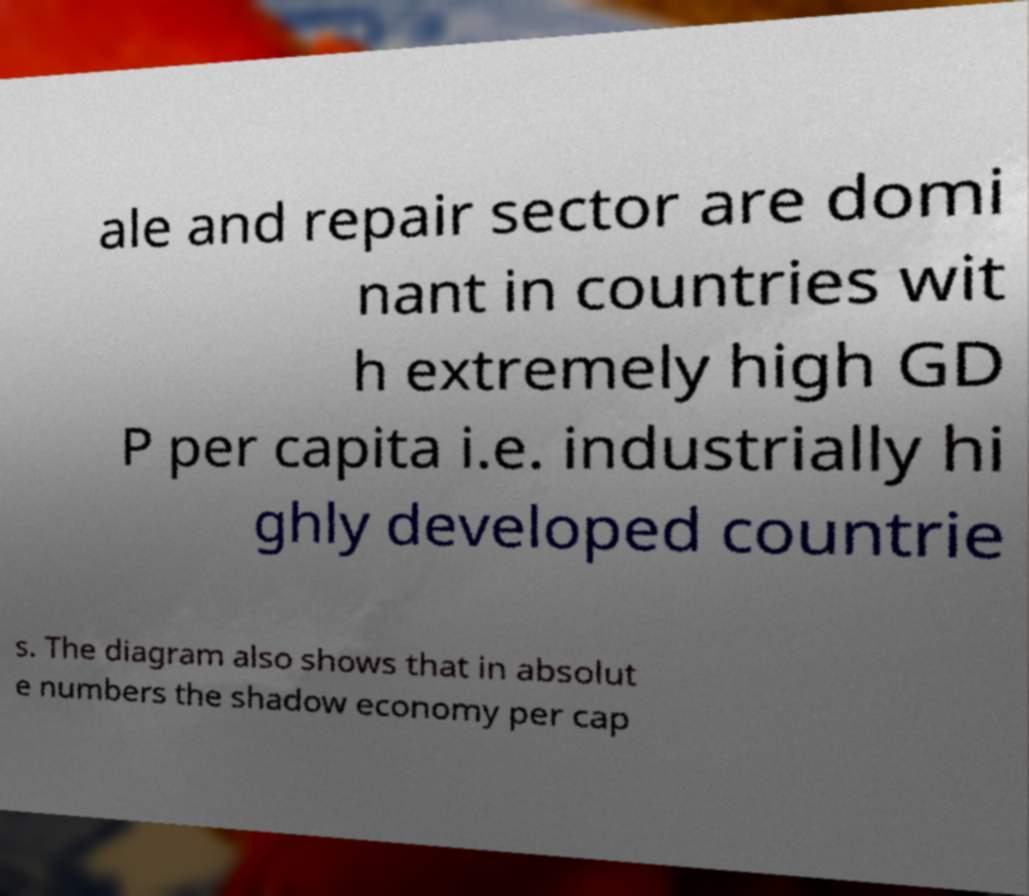Please read and relay the text visible in this image. What does it say? ale and repair sector are domi nant in countries wit h extremely high GD P per capita i.e. industrially hi ghly developed countrie s. The diagram also shows that in absolut e numbers the shadow economy per cap 